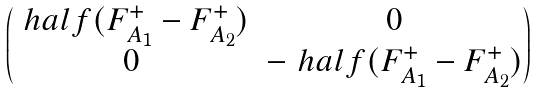Convert formula to latex. <formula><loc_0><loc_0><loc_500><loc_500>\begin{pmatrix} \ h a l f ( F _ { A _ { 1 } } ^ { + } - F _ { A _ { 2 } } ^ { + } ) & 0 \\ 0 & - \ h a l f ( F _ { A _ { 1 } } ^ { + } - F _ { A _ { 2 } } ^ { + } ) \end{pmatrix}</formula> 